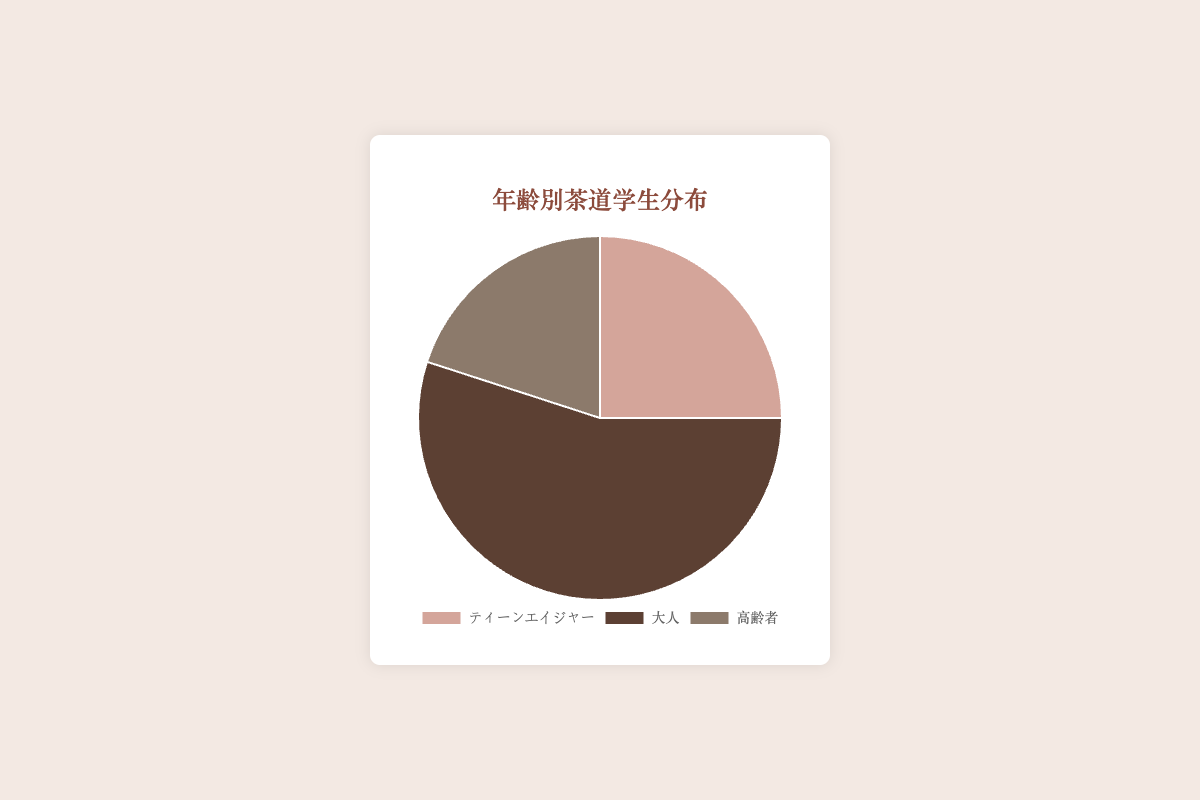What percentage of tea ceremony students are Adults? Look at the section of the pie chart labeled "大人" (Adults). The legend or the label on the chart indicates that this group makes up 55% of the students.
Answer: 55% How does the percentage of Teenagers compare to Seniors? Find the two sections of the pie chart labeled "ティーンエイジャー" (Teenagers) and "高齢者" (Seniors). Teenagers make up 25%, while Seniors make up 20%. Therefore, Teenagers are 5 percentage points more than Seniors.
Answer: Teenagers are 5% more What is the total percentage of Teenagers and Seniors combined? Sum the percentages of Teenagers and Seniors. Teenagers are 25% and Seniors are 20%, so the total is 25% + 20% = 45%.
Answer: 45% Which age group has the smallest representation among tea ceremony students? Compare the percentages of the three age groups labeled on the pie chart. Teenagers are 25%, Adults are 55%, and Seniors are 20%. The smallest percentage is 20%, which corresponds to Seniors.
Answer: Seniors What is the difference in percentage points between the largest and smallest age groups? Identify the largest and smallest groups by their percentages. Adults are the largest at 55%, and Seniors are the smallest at 20%. The difference is 55% - 20% = 35 percentage points.
Answer: 35 percentage points If the pie chart uses three colors, identify the color representing Teenagers. Look at the color of the section labeled "ティーンエイジャー" (Teenagers). The visual attribute of this section is a specific color; according to the provided data, it should be a shade assigned for Teenagers, which is the first color specified.
Answer: The first color specified (Figure-specific) How many more percentage points do Adults have compared to Teenagers? Find the difference between the percentage of Adults and Teenagers. Adults are 55%, and Teenagers are 25%, so the difference is 55% - 25% = 30 percentage points.
Answer: 30 percentage points What is the visual attribute (color) of the group that has the highest percentage? Look at the section with the largest area on the pie chart, labeled "大人" (Adults), and note its color.
Answer: The second color specified (Figure-specific) What percentage of students are not Adults? Subtract the percentage of Adults from 100% since Adults are 55%, the remaining students are 100% - 55% = 45%.
Answer: 45% What is the average percentage of the three age groups? Add the percentages of the three age groups and divide by 3. The groups are 25% (Teenagers), 55% (Adults), and 20% (Seniors). The sum is 25% + 55% + 20% = 100%, so the average is 100% / 3 ≈ 33.33%.
Answer: 33.33% 